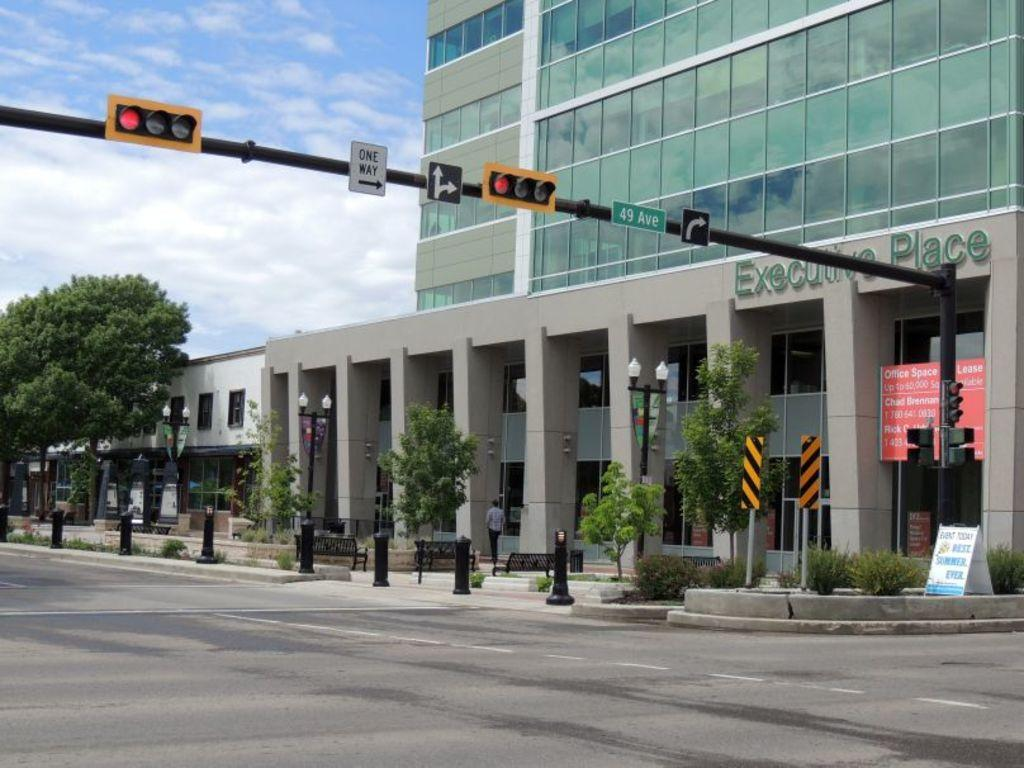<image>
Present a compact description of the photo's key features. the street going by the Executive Place is one way 